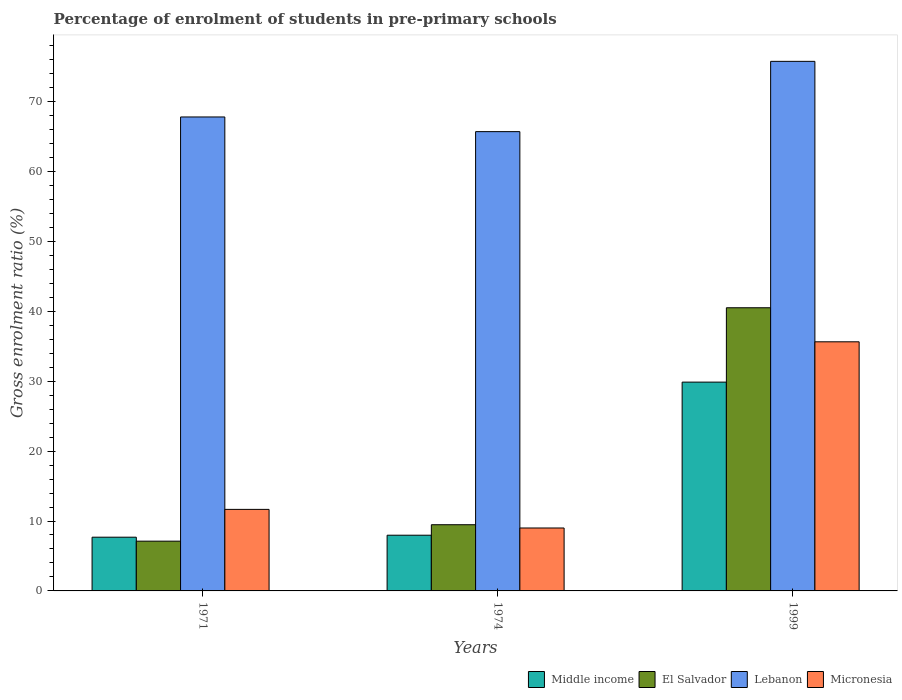How many bars are there on the 1st tick from the left?
Your answer should be compact. 4. In how many cases, is the number of bars for a given year not equal to the number of legend labels?
Your response must be concise. 0. What is the percentage of students enrolled in pre-primary schools in El Salvador in 1971?
Provide a short and direct response. 7.12. Across all years, what is the maximum percentage of students enrolled in pre-primary schools in Micronesia?
Your response must be concise. 35.63. Across all years, what is the minimum percentage of students enrolled in pre-primary schools in El Salvador?
Make the answer very short. 7.12. In which year was the percentage of students enrolled in pre-primary schools in El Salvador maximum?
Keep it short and to the point. 1999. In which year was the percentage of students enrolled in pre-primary schools in Lebanon minimum?
Your answer should be compact. 1974. What is the total percentage of students enrolled in pre-primary schools in Middle income in the graph?
Provide a succinct answer. 45.52. What is the difference between the percentage of students enrolled in pre-primary schools in El Salvador in 1971 and that in 1974?
Provide a short and direct response. -2.35. What is the difference between the percentage of students enrolled in pre-primary schools in Micronesia in 1974 and the percentage of students enrolled in pre-primary schools in El Salvador in 1971?
Provide a succinct answer. 1.88. What is the average percentage of students enrolled in pre-primary schools in El Salvador per year?
Give a very brief answer. 19.03. In the year 1999, what is the difference between the percentage of students enrolled in pre-primary schools in Micronesia and percentage of students enrolled in pre-primary schools in Middle income?
Offer a very short reply. 5.76. In how many years, is the percentage of students enrolled in pre-primary schools in Micronesia greater than 68 %?
Give a very brief answer. 0. What is the ratio of the percentage of students enrolled in pre-primary schools in Middle income in 1971 to that in 1999?
Offer a terse response. 0.26. Is the percentage of students enrolled in pre-primary schools in Middle income in 1974 less than that in 1999?
Ensure brevity in your answer.  Yes. What is the difference between the highest and the second highest percentage of students enrolled in pre-primary schools in El Salvador?
Make the answer very short. 31.03. What is the difference between the highest and the lowest percentage of students enrolled in pre-primary schools in Middle income?
Provide a succinct answer. 22.18. Is it the case that in every year, the sum of the percentage of students enrolled in pre-primary schools in El Salvador and percentage of students enrolled in pre-primary schools in Lebanon is greater than the sum of percentage of students enrolled in pre-primary schools in Middle income and percentage of students enrolled in pre-primary schools in Micronesia?
Offer a very short reply. Yes. What does the 3rd bar from the left in 1999 represents?
Offer a very short reply. Lebanon. What does the 2nd bar from the right in 1971 represents?
Offer a very short reply. Lebanon. Are all the bars in the graph horizontal?
Keep it short and to the point. No. How many years are there in the graph?
Keep it short and to the point. 3. What is the difference between two consecutive major ticks on the Y-axis?
Keep it short and to the point. 10. Does the graph contain grids?
Give a very brief answer. No. Where does the legend appear in the graph?
Offer a terse response. Bottom right. How many legend labels are there?
Provide a succinct answer. 4. How are the legend labels stacked?
Offer a terse response. Horizontal. What is the title of the graph?
Your answer should be compact. Percentage of enrolment of students in pre-primary schools. Does "Middle income" appear as one of the legend labels in the graph?
Give a very brief answer. Yes. What is the Gross enrolment ratio (%) of Middle income in 1971?
Offer a very short reply. 7.68. What is the Gross enrolment ratio (%) of El Salvador in 1971?
Your answer should be compact. 7.12. What is the Gross enrolment ratio (%) of Lebanon in 1971?
Provide a short and direct response. 67.78. What is the Gross enrolment ratio (%) of Micronesia in 1971?
Provide a succinct answer. 11.66. What is the Gross enrolment ratio (%) of Middle income in 1974?
Keep it short and to the point. 7.97. What is the Gross enrolment ratio (%) of El Salvador in 1974?
Give a very brief answer. 9.47. What is the Gross enrolment ratio (%) of Lebanon in 1974?
Give a very brief answer. 65.69. What is the Gross enrolment ratio (%) of Micronesia in 1974?
Give a very brief answer. 9. What is the Gross enrolment ratio (%) in Middle income in 1999?
Provide a short and direct response. 29.86. What is the Gross enrolment ratio (%) of El Salvador in 1999?
Provide a short and direct response. 40.5. What is the Gross enrolment ratio (%) in Lebanon in 1999?
Provide a short and direct response. 75.74. What is the Gross enrolment ratio (%) of Micronesia in 1999?
Provide a succinct answer. 35.63. Across all years, what is the maximum Gross enrolment ratio (%) of Middle income?
Keep it short and to the point. 29.86. Across all years, what is the maximum Gross enrolment ratio (%) in El Salvador?
Your answer should be very brief. 40.5. Across all years, what is the maximum Gross enrolment ratio (%) in Lebanon?
Offer a very short reply. 75.74. Across all years, what is the maximum Gross enrolment ratio (%) in Micronesia?
Offer a terse response. 35.63. Across all years, what is the minimum Gross enrolment ratio (%) in Middle income?
Ensure brevity in your answer.  7.68. Across all years, what is the minimum Gross enrolment ratio (%) of El Salvador?
Give a very brief answer. 7.12. Across all years, what is the minimum Gross enrolment ratio (%) of Lebanon?
Keep it short and to the point. 65.69. Across all years, what is the minimum Gross enrolment ratio (%) in Micronesia?
Offer a very short reply. 9. What is the total Gross enrolment ratio (%) in Middle income in the graph?
Make the answer very short. 45.52. What is the total Gross enrolment ratio (%) in El Salvador in the graph?
Offer a very short reply. 57.08. What is the total Gross enrolment ratio (%) of Lebanon in the graph?
Your answer should be very brief. 209.21. What is the total Gross enrolment ratio (%) in Micronesia in the graph?
Provide a short and direct response. 56.29. What is the difference between the Gross enrolment ratio (%) of Middle income in 1971 and that in 1974?
Your response must be concise. -0.28. What is the difference between the Gross enrolment ratio (%) of El Salvador in 1971 and that in 1974?
Offer a very short reply. -2.35. What is the difference between the Gross enrolment ratio (%) in Lebanon in 1971 and that in 1974?
Offer a very short reply. 2.1. What is the difference between the Gross enrolment ratio (%) of Micronesia in 1971 and that in 1974?
Your answer should be very brief. 2.66. What is the difference between the Gross enrolment ratio (%) of Middle income in 1971 and that in 1999?
Provide a succinct answer. -22.18. What is the difference between the Gross enrolment ratio (%) in El Salvador in 1971 and that in 1999?
Give a very brief answer. -33.38. What is the difference between the Gross enrolment ratio (%) in Lebanon in 1971 and that in 1999?
Keep it short and to the point. -7.95. What is the difference between the Gross enrolment ratio (%) of Micronesia in 1971 and that in 1999?
Offer a very short reply. -23.97. What is the difference between the Gross enrolment ratio (%) of Middle income in 1974 and that in 1999?
Provide a short and direct response. -21.9. What is the difference between the Gross enrolment ratio (%) in El Salvador in 1974 and that in 1999?
Your answer should be very brief. -31.03. What is the difference between the Gross enrolment ratio (%) in Lebanon in 1974 and that in 1999?
Keep it short and to the point. -10.05. What is the difference between the Gross enrolment ratio (%) of Micronesia in 1974 and that in 1999?
Offer a terse response. -26.63. What is the difference between the Gross enrolment ratio (%) in Middle income in 1971 and the Gross enrolment ratio (%) in El Salvador in 1974?
Keep it short and to the point. -1.78. What is the difference between the Gross enrolment ratio (%) of Middle income in 1971 and the Gross enrolment ratio (%) of Lebanon in 1974?
Keep it short and to the point. -58. What is the difference between the Gross enrolment ratio (%) in Middle income in 1971 and the Gross enrolment ratio (%) in Micronesia in 1974?
Provide a succinct answer. -1.32. What is the difference between the Gross enrolment ratio (%) of El Salvador in 1971 and the Gross enrolment ratio (%) of Lebanon in 1974?
Your answer should be very brief. -58.57. What is the difference between the Gross enrolment ratio (%) in El Salvador in 1971 and the Gross enrolment ratio (%) in Micronesia in 1974?
Your response must be concise. -1.88. What is the difference between the Gross enrolment ratio (%) in Lebanon in 1971 and the Gross enrolment ratio (%) in Micronesia in 1974?
Provide a short and direct response. 58.79. What is the difference between the Gross enrolment ratio (%) in Middle income in 1971 and the Gross enrolment ratio (%) in El Salvador in 1999?
Keep it short and to the point. -32.81. What is the difference between the Gross enrolment ratio (%) of Middle income in 1971 and the Gross enrolment ratio (%) of Lebanon in 1999?
Your answer should be very brief. -68.05. What is the difference between the Gross enrolment ratio (%) of Middle income in 1971 and the Gross enrolment ratio (%) of Micronesia in 1999?
Provide a short and direct response. -27.94. What is the difference between the Gross enrolment ratio (%) in El Salvador in 1971 and the Gross enrolment ratio (%) in Lebanon in 1999?
Ensure brevity in your answer.  -68.62. What is the difference between the Gross enrolment ratio (%) in El Salvador in 1971 and the Gross enrolment ratio (%) in Micronesia in 1999?
Keep it short and to the point. -28.51. What is the difference between the Gross enrolment ratio (%) of Lebanon in 1971 and the Gross enrolment ratio (%) of Micronesia in 1999?
Keep it short and to the point. 32.16. What is the difference between the Gross enrolment ratio (%) in Middle income in 1974 and the Gross enrolment ratio (%) in El Salvador in 1999?
Make the answer very short. -32.53. What is the difference between the Gross enrolment ratio (%) of Middle income in 1974 and the Gross enrolment ratio (%) of Lebanon in 1999?
Provide a short and direct response. -67.77. What is the difference between the Gross enrolment ratio (%) in Middle income in 1974 and the Gross enrolment ratio (%) in Micronesia in 1999?
Offer a terse response. -27.66. What is the difference between the Gross enrolment ratio (%) in El Salvador in 1974 and the Gross enrolment ratio (%) in Lebanon in 1999?
Provide a short and direct response. -66.27. What is the difference between the Gross enrolment ratio (%) in El Salvador in 1974 and the Gross enrolment ratio (%) in Micronesia in 1999?
Your answer should be compact. -26.16. What is the difference between the Gross enrolment ratio (%) in Lebanon in 1974 and the Gross enrolment ratio (%) in Micronesia in 1999?
Your answer should be very brief. 30.06. What is the average Gross enrolment ratio (%) in Middle income per year?
Provide a short and direct response. 15.17. What is the average Gross enrolment ratio (%) of El Salvador per year?
Make the answer very short. 19.03. What is the average Gross enrolment ratio (%) in Lebanon per year?
Make the answer very short. 69.74. What is the average Gross enrolment ratio (%) of Micronesia per year?
Give a very brief answer. 18.76. In the year 1971, what is the difference between the Gross enrolment ratio (%) of Middle income and Gross enrolment ratio (%) of El Salvador?
Ensure brevity in your answer.  0.57. In the year 1971, what is the difference between the Gross enrolment ratio (%) of Middle income and Gross enrolment ratio (%) of Lebanon?
Offer a terse response. -60.1. In the year 1971, what is the difference between the Gross enrolment ratio (%) in Middle income and Gross enrolment ratio (%) in Micronesia?
Your response must be concise. -3.98. In the year 1971, what is the difference between the Gross enrolment ratio (%) of El Salvador and Gross enrolment ratio (%) of Lebanon?
Your response must be concise. -60.67. In the year 1971, what is the difference between the Gross enrolment ratio (%) in El Salvador and Gross enrolment ratio (%) in Micronesia?
Ensure brevity in your answer.  -4.55. In the year 1971, what is the difference between the Gross enrolment ratio (%) of Lebanon and Gross enrolment ratio (%) of Micronesia?
Your response must be concise. 56.12. In the year 1974, what is the difference between the Gross enrolment ratio (%) in Middle income and Gross enrolment ratio (%) in El Salvador?
Make the answer very short. -1.5. In the year 1974, what is the difference between the Gross enrolment ratio (%) of Middle income and Gross enrolment ratio (%) of Lebanon?
Your answer should be very brief. -57.72. In the year 1974, what is the difference between the Gross enrolment ratio (%) in Middle income and Gross enrolment ratio (%) in Micronesia?
Keep it short and to the point. -1.03. In the year 1974, what is the difference between the Gross enrolment ratio (%) in El Salvador and Gross enrolment ratio (%) in Lebanon?
Keep it short and to the point. -56.22. In the year 1974, what is the difference between the Gross enrolment ratio (%) in El Salvador and Gross enrolment ratio (%) in Micronesia?
Keep it short and to the point. 0.47. In the year 1974, what is the difference between the Gross enrolment ratio (%) of Lebanon and Gross enrolment ratio (%) of Micronesia?
Your response must be concise. 56.69. In the year 1999, what is the difference between the Gross enrolment ratio (%) in Middle income and Gross enrolment ratio (%) in El Salvador?
Give a very brief answer. -10.63. In the year 1999, what is the difference between the Gross enrolment ratio (%) of Middle income and Gross enrolment ratio (%) of Lebanon?
Give a very brief answer. -45.87. In the year 1999, what is the difference between the Gross enrolment ratio (%) in Middle income and Gross enrolment ratio (%) in Micronesia?
Offer a very short reply. -5.76. In the year 1999, what is the difference between the Gross enrolment ratio (%) of El Salvador and Gross enrolment ratio (%) of Lebanon?
Provide a succinct answer. -35.24. In the year 1999, what is the difference between the Gross enrolment ratio (%) in El Salvador and Gross enrolment ratio (%) in Micronesia?
Keep it short and to the point. 4.87. In the year 1999, what is the difference between the Gross enrolment ratio (%) in Lebanon and Gross enrolment ratio (%) in Micronesia?
Your response must be concise. 40.11. What is the ratio of the Gross enrolment ratio (%) of El Salvador in 1971 to that in 1974?
Keep it short and to the point. 0.75. What is the ratio of the Gross enrolment ratio (%) in Lebanon in 1971 to that in 1974?
Ensure brevity in your answer.  1.03. What is the ratio of the Gross enrolment ratio (%) of Micronesia in 1971 to that in 1974?
Keep it short and to the point. 1.3. What is the ratio of the Gross enrolment ratio (%) of Middle income in 1971 to that in 1999?
Provide a short and direct response. 0.26. What is the ratio of the Gross enrolment ratio (%) in El Salvador in 1971 to that in 1999?
Offer a terse response. 0.18. What is the ratio of the Gross enrolment ratio (%) in Lebanon in 1971 to that in 1999?
Your response must be concise. 0.9. What is the ratio of the Gross enrolment ratio (%) in Micronesia in 1971 to that in 1999?
Ensure brevity in your answer.  0.33. What is the ratio of the Gross enrolment ratio (%) of Middle income in 1974 to that in 1999?
Offer a very short reply. 0.27. What is the ratio of the Gross enrolment ratio (%) of El Salvador in 1974 to that in 1999?
Provide a short and direct response. 0.23. What is the ratio of the Gross enrolment ratio (%) of Lebanon in 1974 to that in 1999?
Give a very brief answer. 0.87. What is the ratio of the Gross enrolment ratio (%) in Micronesia in 1974 to that in 1999?
Your answer should be very brief. 0.25. What is the difference between the highest and the second highest Gross enrolment ratio (%) in Middle income?
Ensure brevity in your answer.  21.9. What is the difference between the highest and the second highest Gross enrolment ratio (%) of El Salvador?
Provide a short and direct response. 31.03. What is the difference between the highest and the second highest Gross enrolment ratio (%) in Lebanon?
Keep it short and to the point. 7.95. What is the difference between the highest and the second highest Gross enrolment ratio (%) in Micronesia?
Provide a succinct answer. 23.97. What is the difference between the highest and the lowest Gross enrolment ratio (%) of Middle income?
Ensure brevity in your answer.  22.18. What is the difference between the highest and the lowest Gross enrolment ratio (%) in El Salvador?
Offer a terse response. 33.38. What is the difference between the highest and the lowest Gross enrolment ratio (%) in Lebanon?
Offer a terse response. 10.05. What is the difference between the highest and the lowest Gross enrolment ratio (%) in Micronesia?
Your answer should be compact. 26.63. 